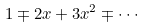Convert formula to latex. <formula><loc_0><loc_0><loc_500><loc_500>1 \mp 2 x + 3 x ^ { 2 } \mp \cdot \cdot \cdot</formula> 